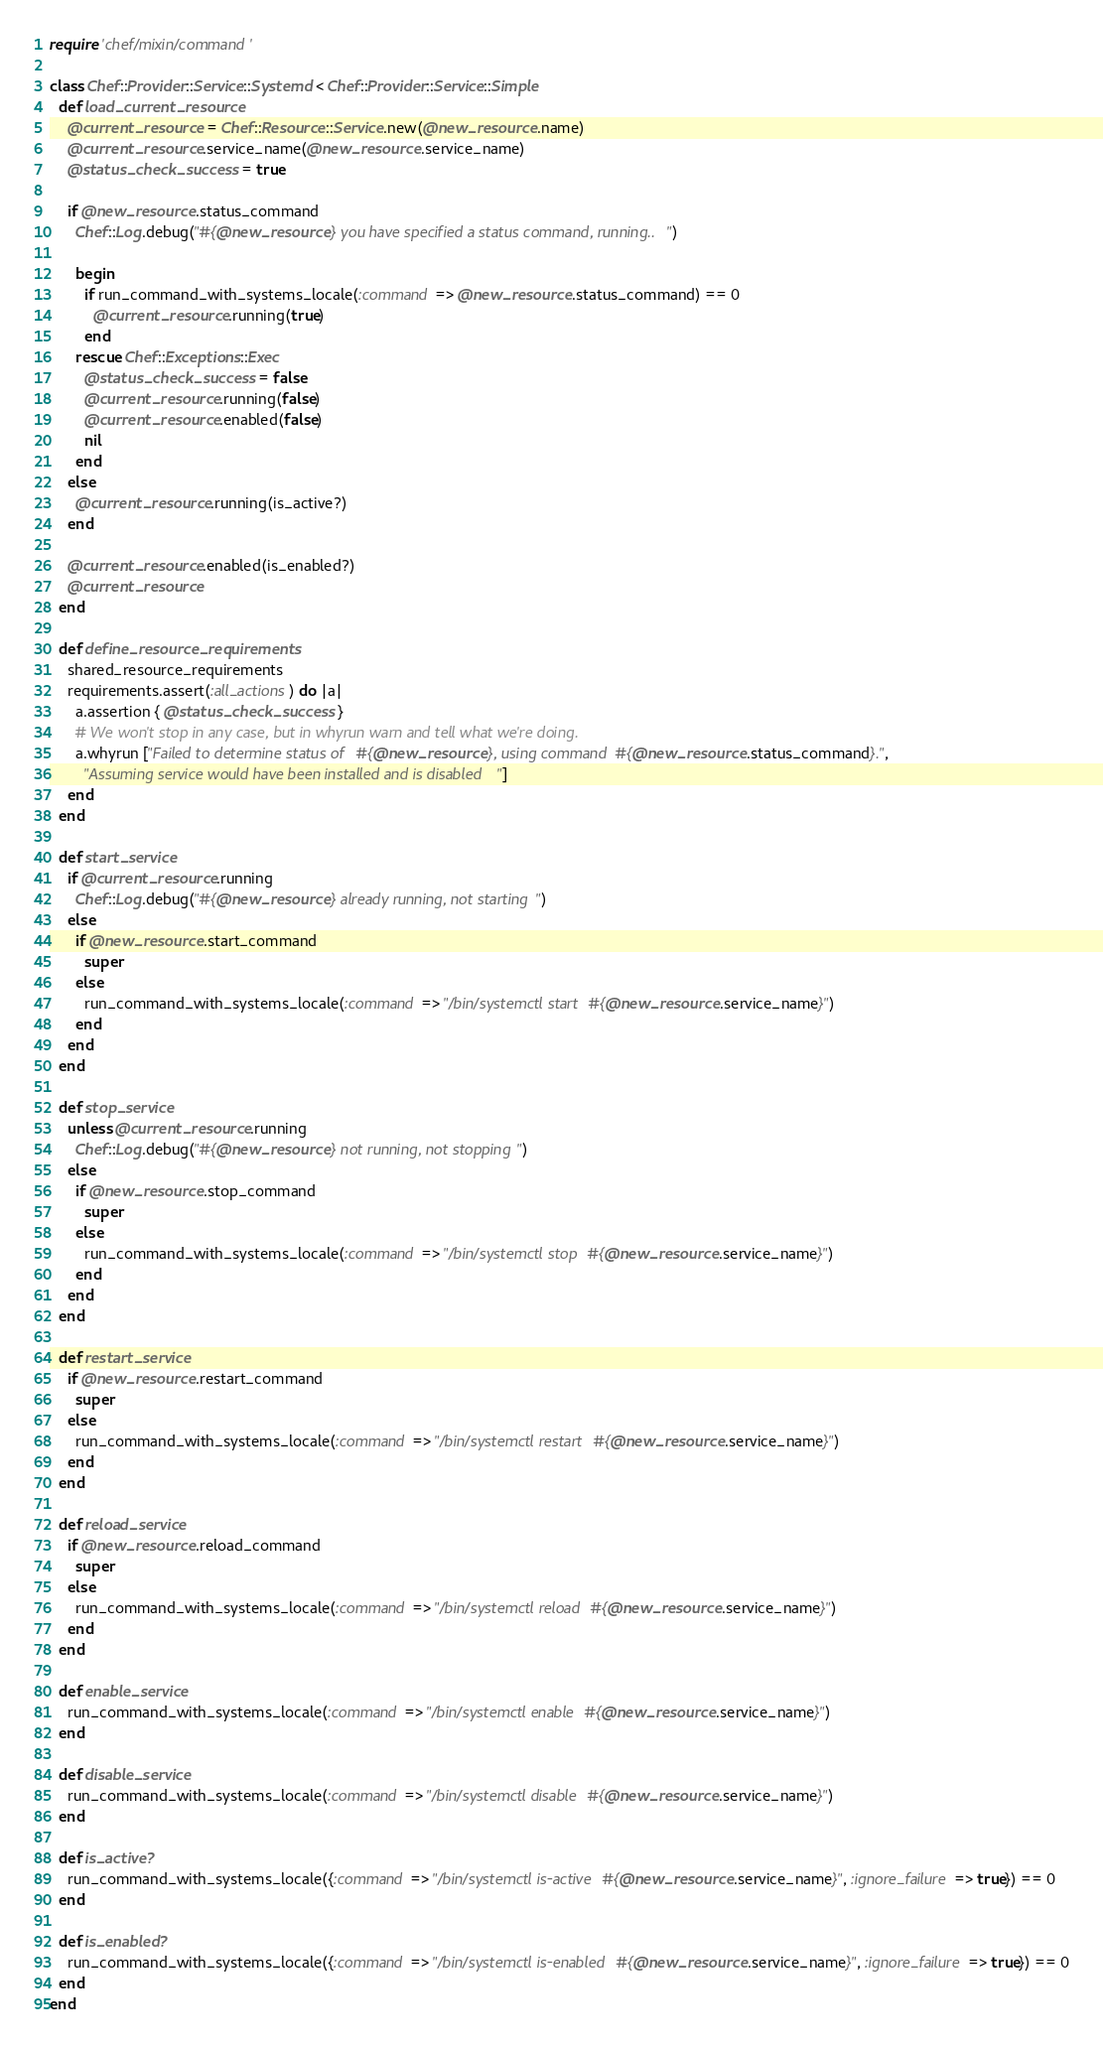<code> <loc_0><loc_0><loc_500><loc_500><_Ruby_>require 'chef/mixin/command'

class Chef::Provider::Service::Systemd < Chef::Provider::Service::Simple
  def load_current_resource
    @current_resource = Chef::Resource::Service.new(@new_resource.name)
    @current_resource.service_name(@new_resource.service_name)
    @status_check_success = true

    if @new_resource.status_command
      Chef::Log.debug("#{@new_resource} you have specified a status command, running..")

      begin
        if run_command_with_systems_locale(:command => @new_resource.status_command) == 0
          @current_resource.running(true)
        end
      rescue Chef::Exceptions::Exec
        @status_check_success = false
        @current_resource.running(false)
        @current_resource.enabled(false)
        nil
      end
    else
      @current_resource.running(is_active?)
    end

    @current_resource.enabled(is_enabled?)
    @current_resource
  end

  def define_resource_requirements
    shared_resource_requirements
    requirements.assert(:all_actions) do |a|
      a.assertion { @status_check_success }
      # We won't stop in any case, but in whyrun warn and tell what we're doing.
      a.whyrun ["Failed to determine status of #{@new_resource}, using command #{@new_resource.status_command}.",
        "Assuming service would have been installed and is disabled"]
    end
  end

  def start_service
    if @current_resource.running
      Chef::Log.debug("#{@new_resource} already running, not starting")
    else
      if @new_resource.start_command
        super
      else
        run_command_with_systems_locale(:command => "/bin/systemctl start #{@new_resource.service_name}")
      end
    end
  end

  def stop_service
    unless @current_resource.running
      Chef::Log.debug("#{@new_resource} not running, not stopping")
    else
      if @new_resource.stop_command
        super
      else
        run_command_with_systems_locale(:command => "/bin/systemctl stop #{@new_resource.service_name}")
      end
    end
  end

  def restart_service
    if @new_resource.restart_command
      super
    else
      run_command_with_systems_locale(:command => "/bin/systemctl restart #{@new_resource.service_name}")
    end
  end

  def reload_service
    if @new_resource.reload_command
      super
    else
      run_command_with_systems_locale(:command => "/bin/systemctl reload #{@new_resource.service_name}")
    end
  end

  def enable_service
    run_command_with_systems_locale(:command => "/bin/systemctl enable #{@new_resource.service_name}")
  end

  def disable_service
    run_command_with_systems_locale(:command => "/bin/systemctl disable #{@new_resource.service_name}")
  end

  def is_active?
    run_command_with_systems_locale({:command => "/bin/systemctl is-active #{@new_resource.service_name}", :ignore_failure => true}) == 0
  end

  def is_enabled?
    run_command_with_systems_locale({:command => "/bin/systemctl is-enabled #{@new_resource.service_name}", :ignore_failure => true}) == 0
  end
end
</code> 